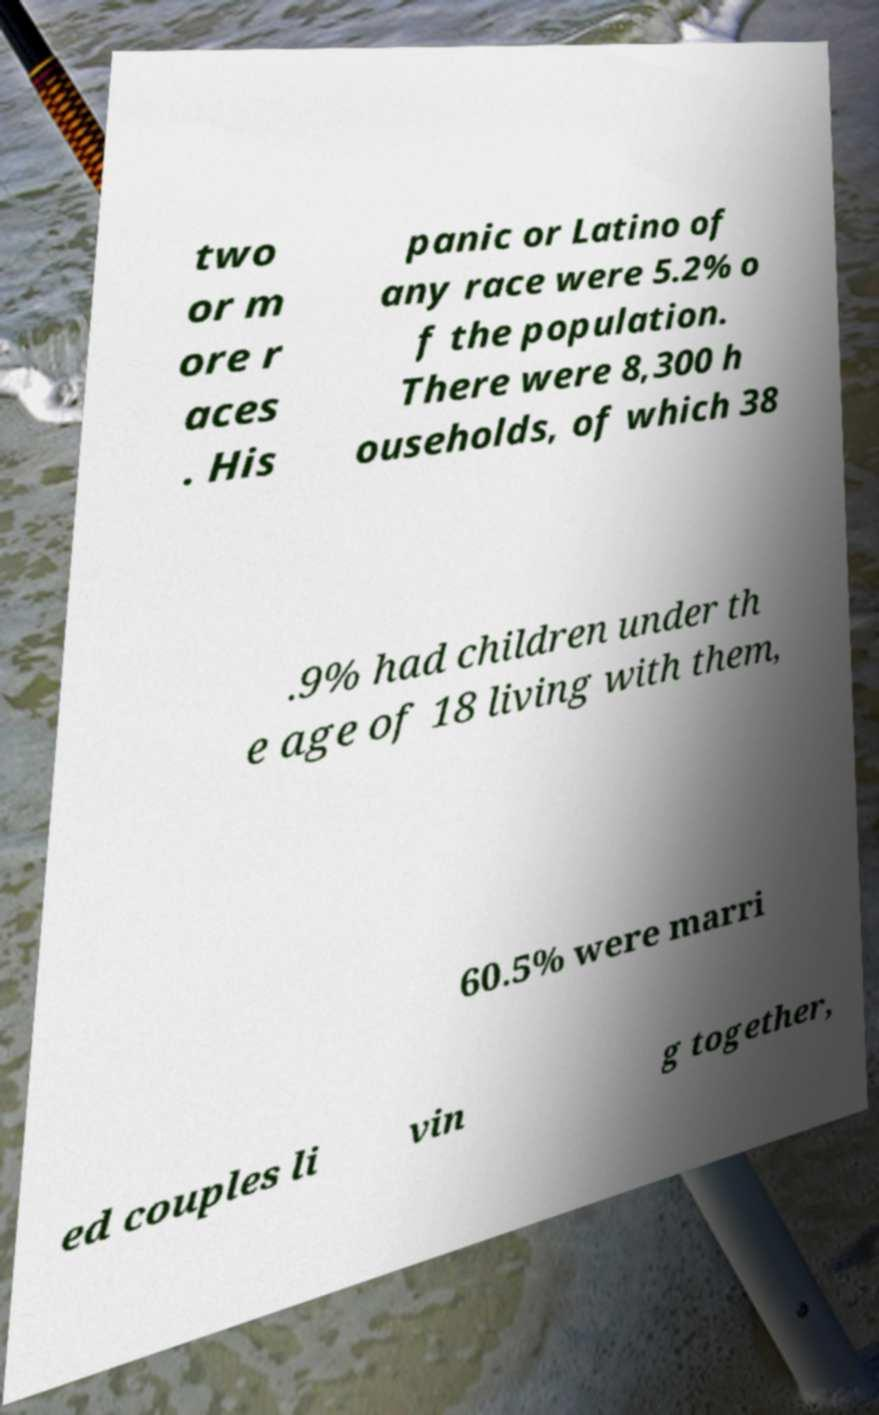Please identify and transcribe the text found in this image. two or m ore r aces . His panic or Latino of any race were 5.2% o f the population. There were 8,300 h ouseholds, of which 38 .9% had children under th e age of 18 living with them, 60.5% were marri ed couples li vin g together, 